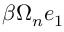Convert formula to latex. <formula><loc_0><loc_0><loc_500><loc_500>\beta \Omega _ { n } e _ { 1 }</formula> 